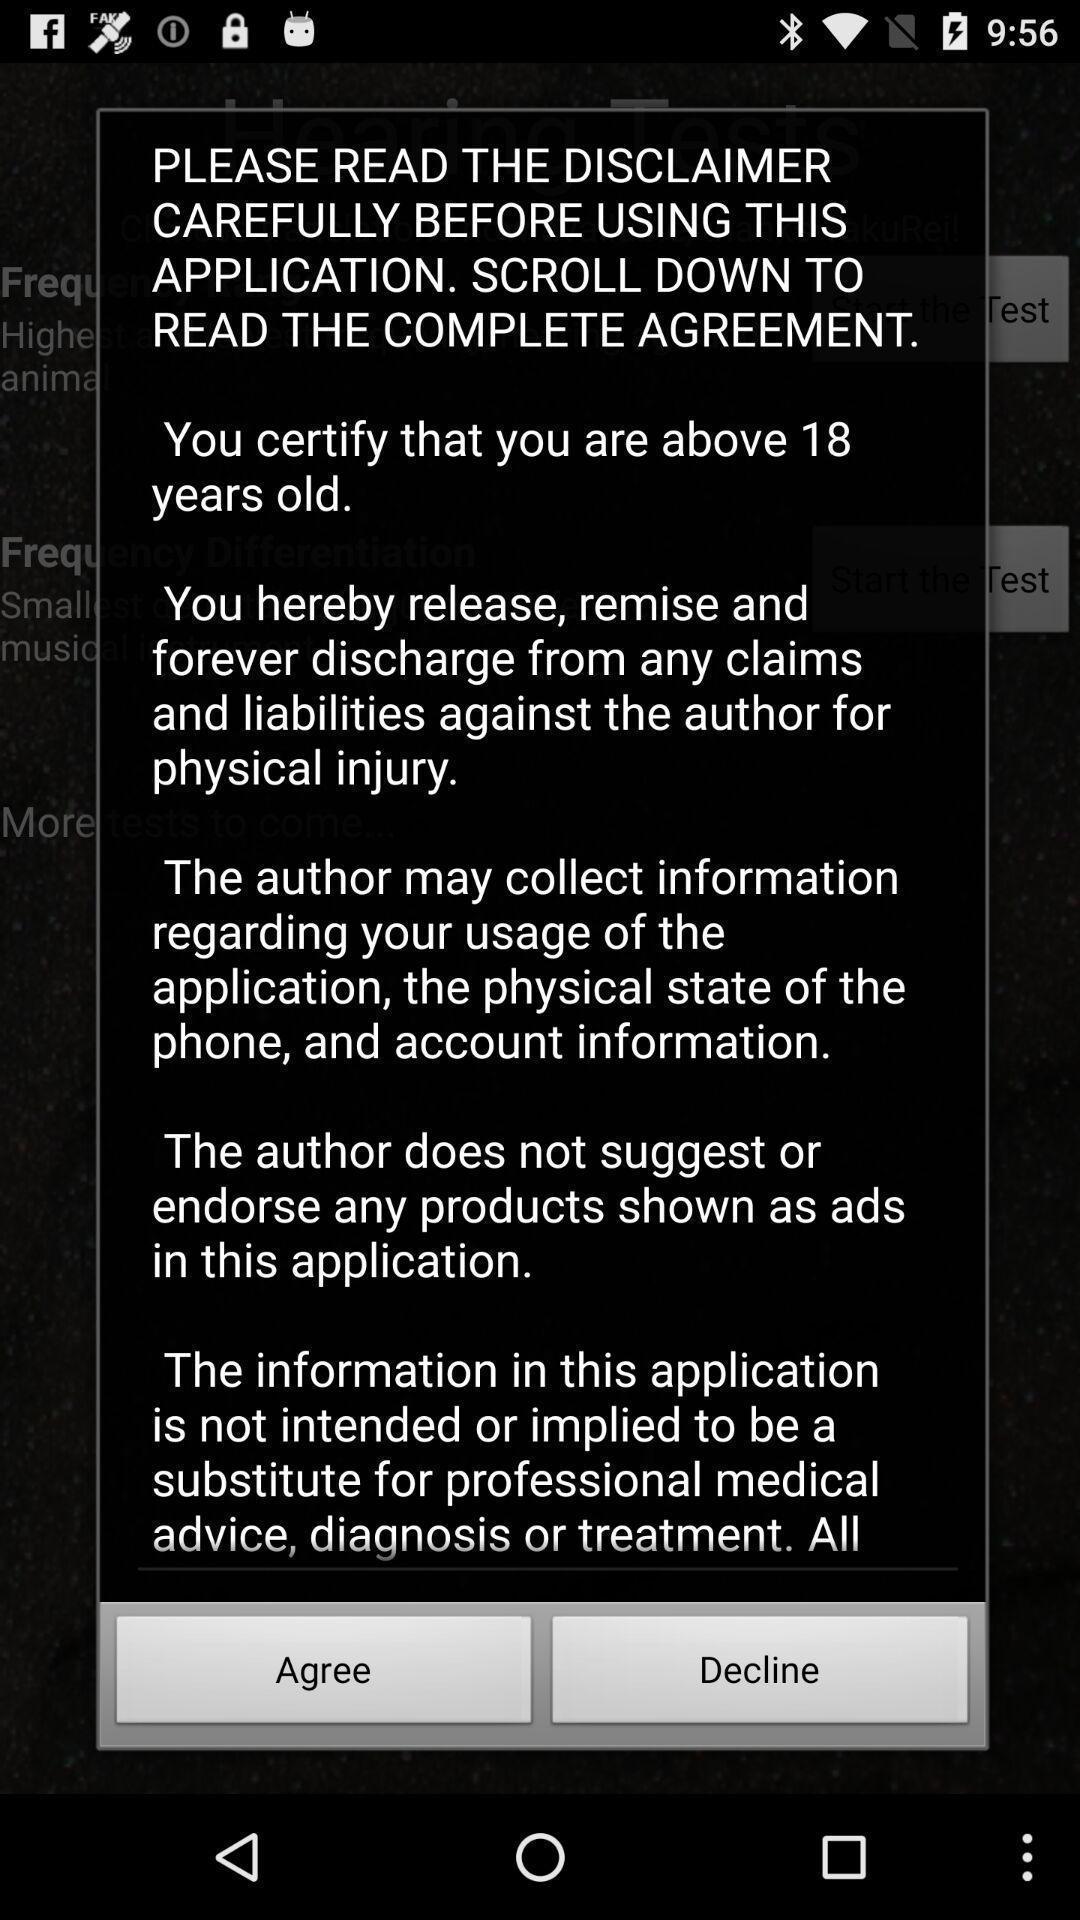Describe the key features of this screenshot. Pop-up showing option like agree. 